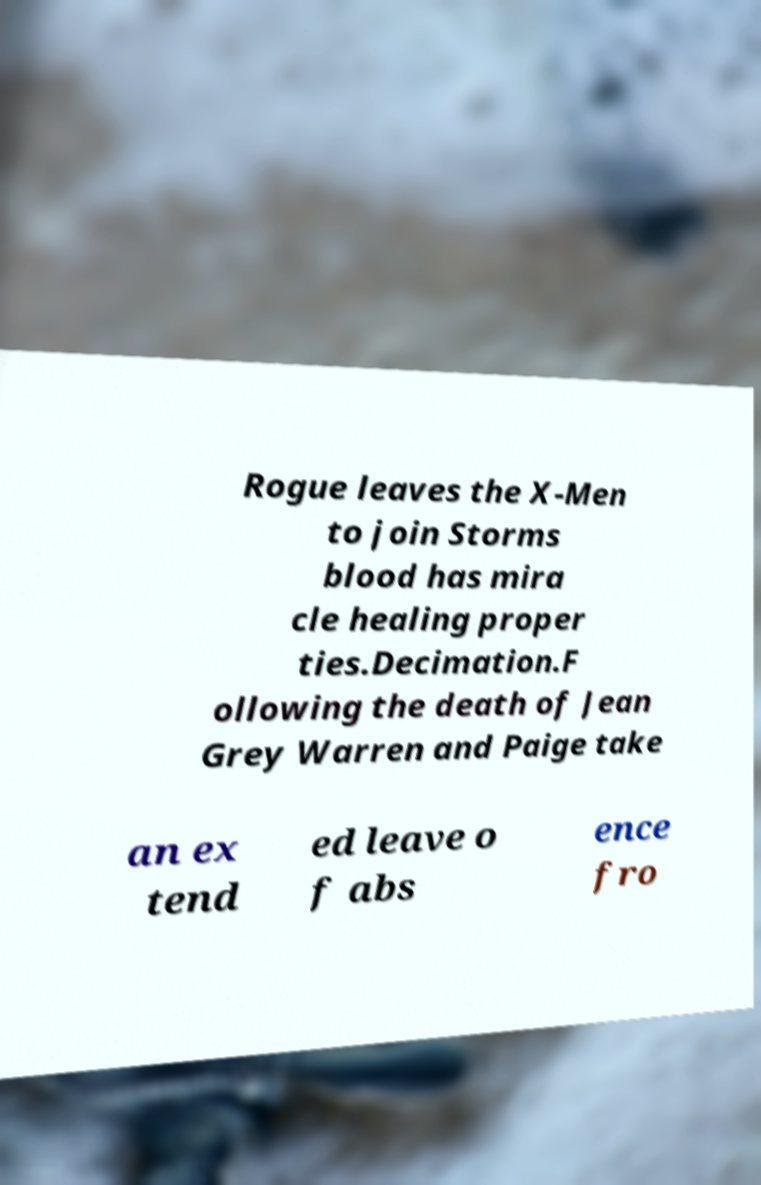Can you read and provide the text displayed in the image?This photo seems to have some interesting text. Can you extract and type it out for me? Rogue leaves the X-Men to join Storms blood has mira cle healing proper ties.Decimation.F ollowing the death of Jean Grey Warren and Paige take an ex tend ed leave o f abs ence fro 